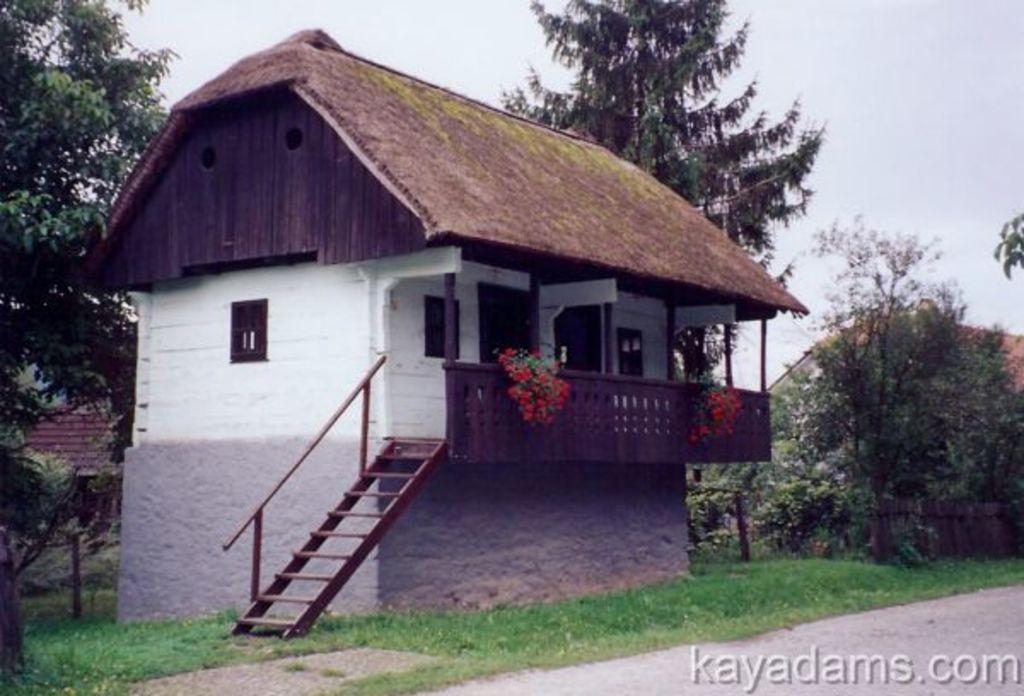Describe this image in one or two sentences. In this image we can see a building with windows, steps with railings. Also there are pillars and another railing. On that there are flowering plants. On the ground there is grass. Also there are trees. In the background there is sky. In the right bottom corner something is written. In the background there are buildings. 